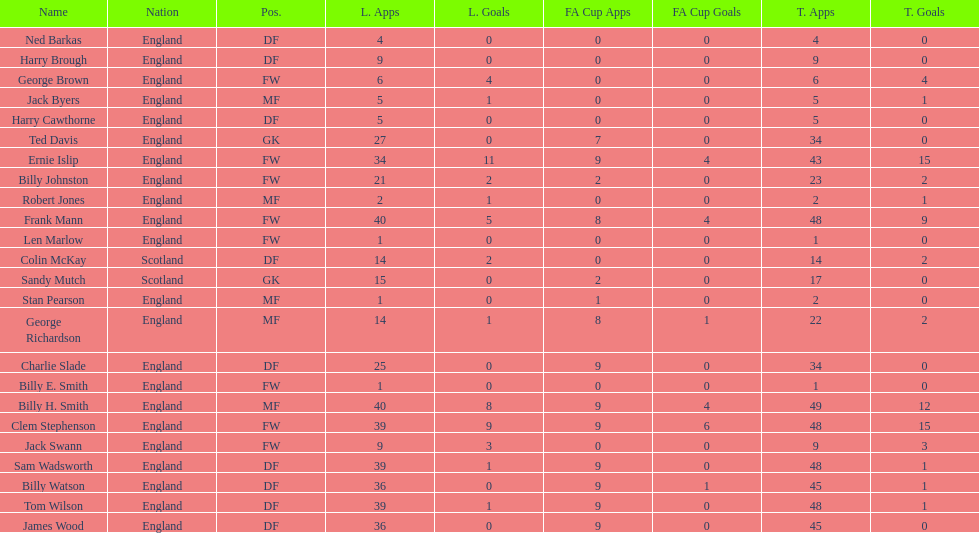Help me parse the entirety of this table. {'header': ['Name', 'Nation', 'Pos.', 'L. Apps', 'L. Goals', 'FA Cup Apps', 'FA Cup Goals', 'T. Apps', 'T. Goals'], 'rows': [['Ned Barkas', 'England', 'DF', '4', '0', '0', '0', '4', '0'], ['Harry Brough', 'England', 'DF', '9', '0', '0', '0', '9', '0'], ['George Brown', 'England', 'FW', '6', '4', '0', '0', '6', '4'], ['Jack Byers', 'England', 'MF', '5', '1', '0', '0', '5', '1'], ['Harry Cawthorne', 'England', 'DF', '5', '0', '0', '0', '5', '0'], ['Ted Davis', 'England', 'GK', '27', '0', '7', '0', '34', '0'], ['Ernie Islip', 'England', 'FW', '34', '11', '9', '4', '43', '15'], ['Billy Johnston', 'England', 'FW', '21', '2', '2', '0', '23', '2'], ['Robert Jones', 'England', 'MF', '2', '1', '0', '0', '2', '1'], ['Frank Mann', 'England', 'FW', '40', '5', '8', '4', '48', '9'], ['Len Marlow', 'England', 'FW', '1', '0', '0', '0', '1', '0'], ['Colin McKay', 'Scotland', 'DF', '14', '2', '0', '0', '14', '2'], ['Sandy Mutch', 'Scotland', 'GK', '15', '0', '2', '0', '17', '0'], ['Stan Pearson', 'England', 'MF', '1', '0', '1', '0', '2', '0'], ['George Richardson', 'England', 'MF', '14', '1', '8', '1', '22', '2'], ['Charlie Slade', 'England', 'DF', '25', '0', '9', '0', '34', '0'], ['Billy E. Smith', 'England', 'FW', '1', '0', '0', '0', '1', '0'], ['Billy H. Smith', 'England', 'MF', '40', '8', '9', '4', '49', '12'], ['Clem Stephenson', 'England', 'FW', '39', '9', '9', '6', '48', '15'], ['Jack Swann', 'England', 'FW', '9', '3', '0', '0', '9', '3'], ['Sam Wadsworth', 'England', 'DF', '39', '1', '9', '0', '48', '1'], ['Billy Watson', 'England', 'DF', '36', '0', '9', '1', '45', '1'], ['Tom Wilson', 'England', 'DF', '39', '1', '9', '0', '48', '1'], ['James Wood', 'England', 'DF', '36', '0', '9', '0', '45', '0']]} What is the last name listed on this chart? James Wood. 